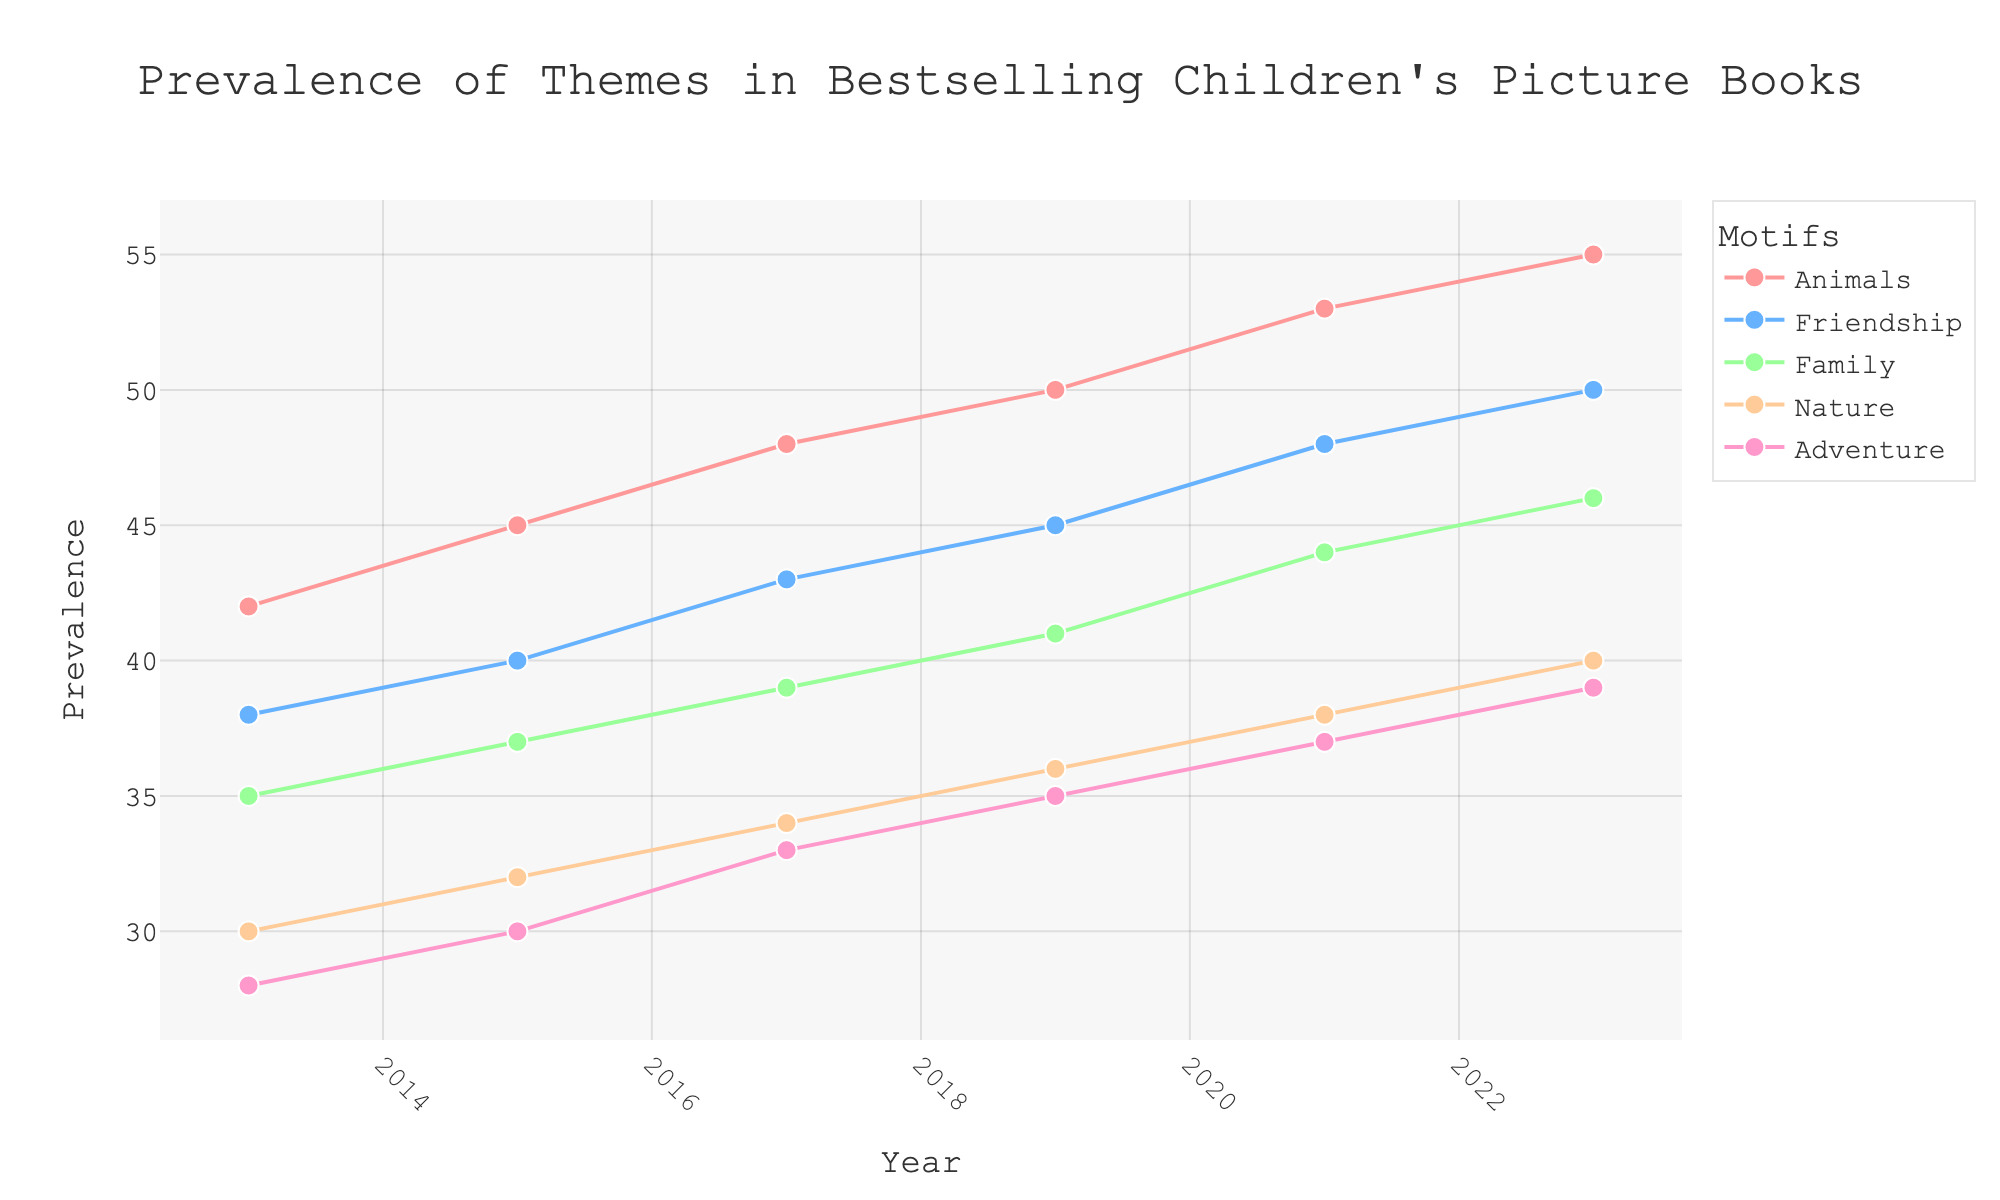what is the title of the plot? The title is usually located at the top of the plot and gives you a quick idea of what the plot represents.
Answer: Prevalence of Themes in Bestselling Children's Picture Books what is the prevalence of 'Animals' in 2019? Look for the marker and line corresponding to 'Animals' in the year 2019 and read off the y-axis value.
Answer: 50 which motif showed the lowest prevalence in 2023? Compare the y-axis values for each motif in the year 2023 and identify the lowest one.
Answer: Adventure how does the prevalence of 'Family' change from 2013 to 2023? Track the trend of the 'Family' motif from 2013 to 2023, noting the increase or decrease in y-axis values.
Answer: Increased from 35 to 46 by how much did the prevalence of 'Nature' increase between 2015 and 2021? Find the prevalence values for 'Nature' in 2015 and 2021, then subtract the earlier value from the later value.
Answer: Increased by 6 which motif had the most consistent increase in prevalence over the years? Compare the trends of all motifs from 2013 to 2023 and identify the one with the most consistent upward trend.
Answer: Animals was there any motif whose prevalence decreased at any point within the timeline? Look for any motifs where the y-axis values decrease between any two consecutive years.
Answer: No on what year was the prevalence of 'Friendship' first greater than 45? Look for the year when the y-axis value for 'Friendship' first surpasses 45.
Answer: 2019 what is the average prevalence of 'Adventure' across all years? Sum the prevalence of 'Adventure' for each year and divide by the number of years (5).
Answer: 34.4 